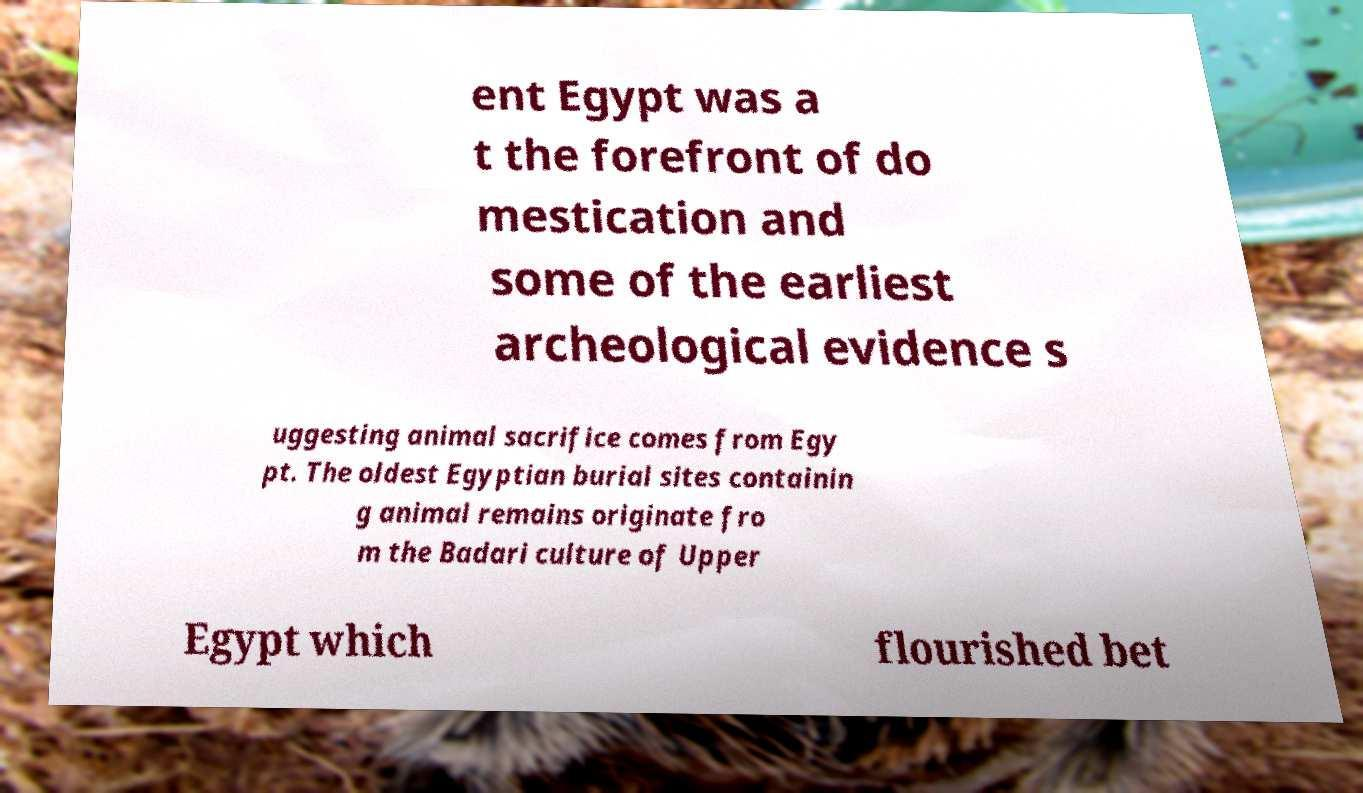Can you read and provide the text displayed in the image?This photo seems to have some interesting text. Can you extract and type it out for me? ent Egypt was a t the forefront of do mestication and some of the earliest archeological evidence s uggesting animal sacrifice comes from Egy pt. The oldest Egyptian burial sites containin g animal remains originate fro m the Badari culture of Upper Egypt which flourished bet 